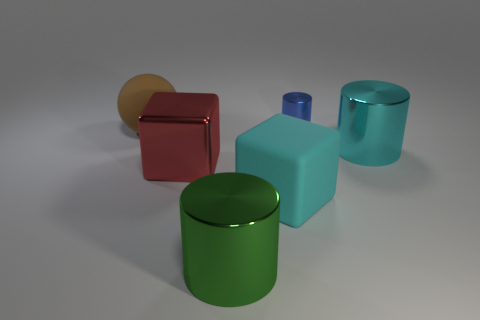Subtract all blue cylinders. How many cylinders are left? 2 Subtract all blue cylinders. How many cylinders are left? 2 Subtract 1 cylinders. How many cylinders are left? 2 Subtract all blue cylinders. Subtract all red blocks. How many cylinders are left? 2 Subtract all yellow cubes. How many purple cylinders are left? 0 Subtract all green objects. Subtract all small red blocks. How many objects are left? 5 Add 1 large red metal objects. How many large red metal objects are left? 2 Add 4 green shiny cylinders. How many green shiny cylinders exist? 5 Add 2 small shiny objects. How many objects exist? 8 Subtract 0 blue blocks. How many objects are left? 6 